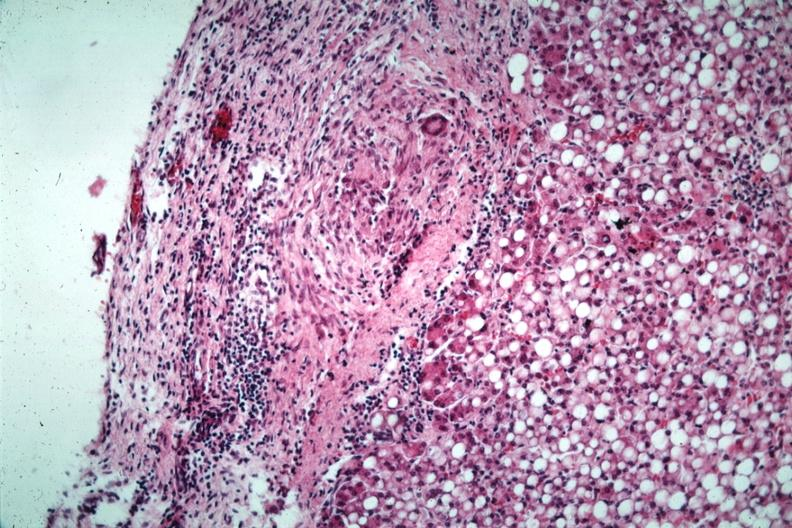s tuberculous peritonitis present?
Answer the question using a single word or phrase. Yes 